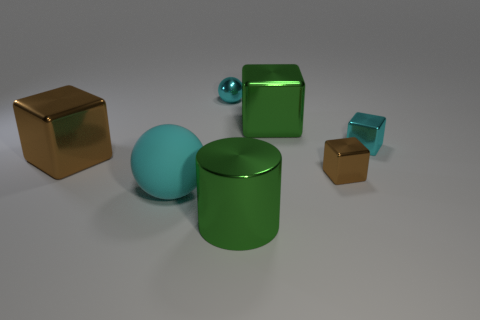Are there any small balls right of the green object that is in front of the large sphere?
Provide a short and direct response. No. Are there fewer blocks on the right side of the shiny cylinder than balls?
Make the answer very short. No. Do the cyan sphere that is behind the large cyan rubber ball and the large brown cube have the same material?
Offer a very short reply. Yes. The cylinder that is made of the same material as the large brown object is what color?
Your answer should be very brief. Green. Are there fewer large brown metal cubes that are behind the cyan shiny block than large metallic objects that are behind the large metallic cylinder?
Offer a terse response. Yes. There is a big block left of the large rubber ball; is it the same color as the small shiny thing that is left of the big metallic cylinder?
Give a very brief answer. No. Is there a tiny block that has the same material as the large cyan thing?
Ensure brevity in your answer.  No. What size is the metal thing left of the small cyan object that is on the left side of the small brown object?
Your response must be concise. Large. Is the number of small gray cubes greater than the number of cylinders?
Keep it short and to the point. No. There is a metal cube on the left side of the cyan metal sphere; is its size the same as the big cyan thing?
Your answer should be very brief. Yes. 